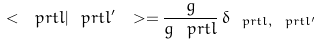<formula> <loc_0><loc_0><loc_500><loc_500>\ < \ p r t { l } | \ p r t { l ^ { \prime } } \ > = \frac { g } { g _ { \ } p r t { l } } \, \delta _ { \ p r t { l } , \ p r t { l ^ { \prime } } }</formula> 